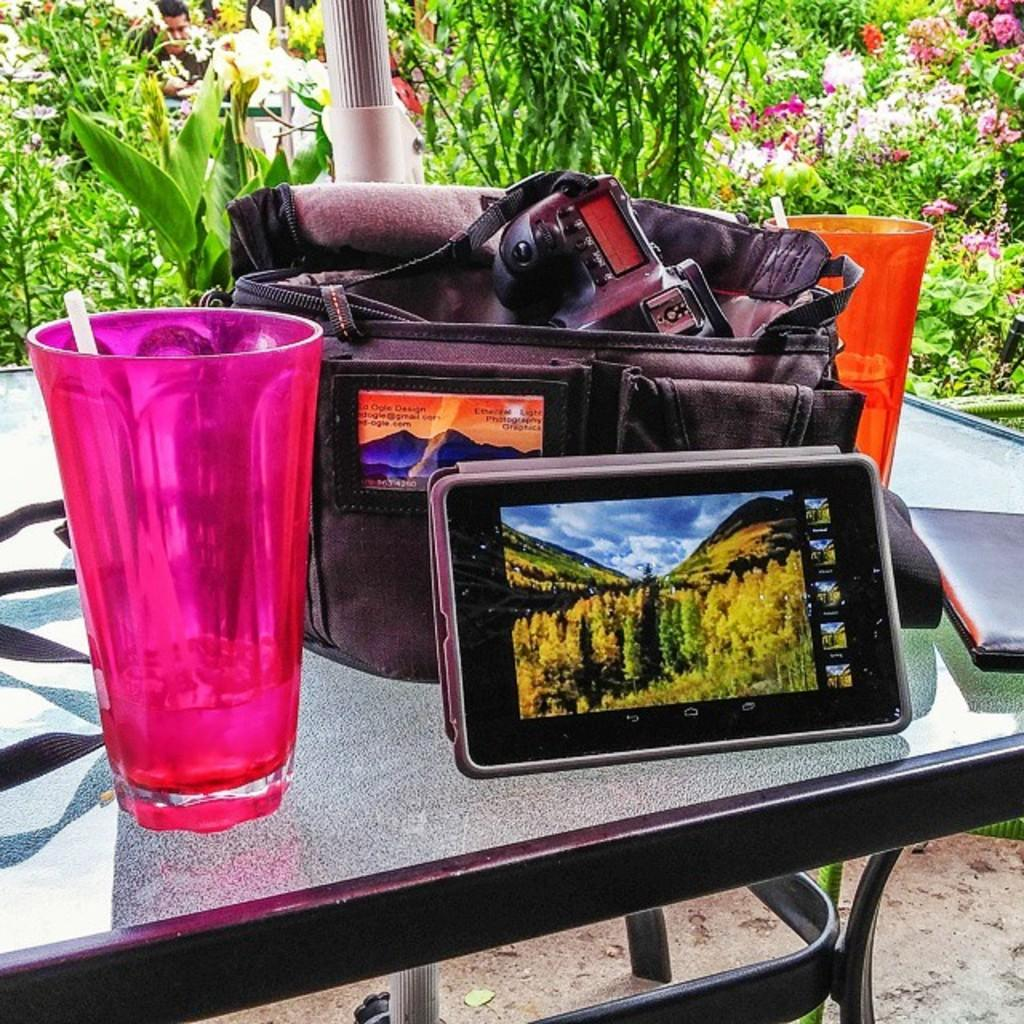What is the main object in the image? There is a table in the image. What items can be seen on the table? A pink glass, a mobile phone, a black bag, an orange glass, and a book are placed on the table. What can be seen in the background of the image? Trees and plants are visible in the background of the image. What reason does the book give for the existence of beds in the image? There are no beds present in the image, and therefore no reason can be given by the book. 